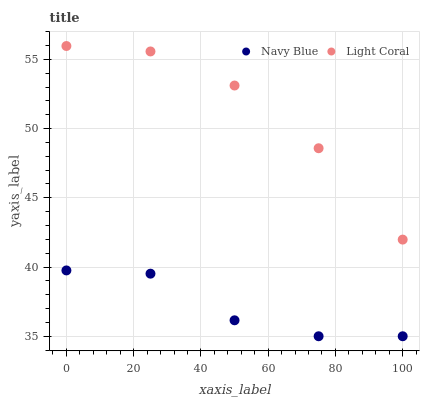Does Navy Blue have the minimum area under the curve?
Answer yes or no. Yes. Does Light Coral have the maximum area under the curve?
Answer yes or no. Yes. Does Navy Blue have the maximum area under the curve?
Answer yes or no. No. Is Light Coral the smoothest?
Answer yes or no. Yes. Is Navy Blue the roughest?
Answer yes or no. Yes. Is Navy Blue the smoothest?
Answer yes or no. No. Does Navy Blue have the lowest value?
Answer yes or no. Yes. Does Light Coral have the highest value?
Answer yes or no. Yes. Does Navy Blue have the highest value?
Answer yes or no. No. Is Navy Blue less than Light Coral?
Answer yes or no. Yes. Is Light Coral greater than Navy Blue?
Answer yes or no. Yes. Does Navy Blue intersect Light Coral?
Answer yes or no. No. 